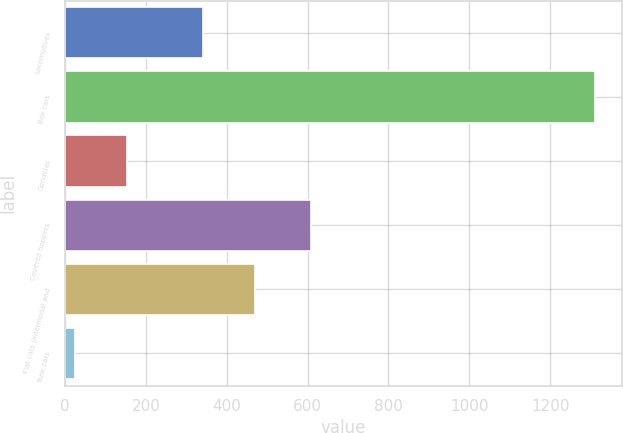Convert chart. <chart><loc_0><loc_0><loc_500><loc_500><bar_chart><fcel>Locomotives<fcel>Box cars<fcel>Gondolas<fcel>Covered hoppers<fcel>Flat cars (intermodal and<fcel>Tank cars<nl><fcel>341<fcel>1312<fcel>152.8<fcel>608<fcel>469.8<fcel>24<nl></chart> 